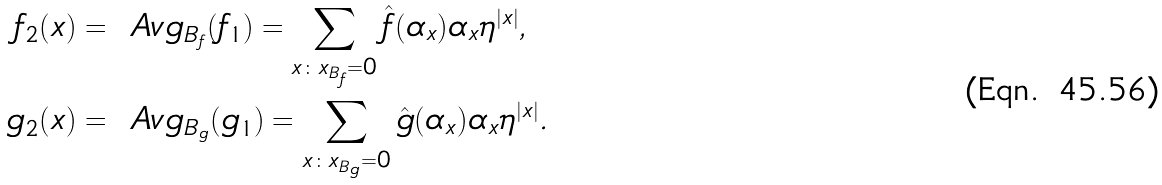<formula> <loc_0><loc_0><loc_500><loc_500>f _ { 2 } ( x ) & = \ A v g _ { B _ { f } } ( f _ { 1 } ) = \sum _ { x \colon x _ { B _ { f } } = 0 } \hat { f } ( \alpha _ { x } ) \alpha _ { x } \eta ^ { | x | } , \\ g _ { 2 } ( x ) & = \ A v g _ { B _ { g } } ( g _ { 1 } ) = \sum _ { x \colon x _ { B _ { g } } = 0 } \hat { g } ( \alpha _ { x } ) \alpha _ { x } \eta ^ { | x | } .</formula> 